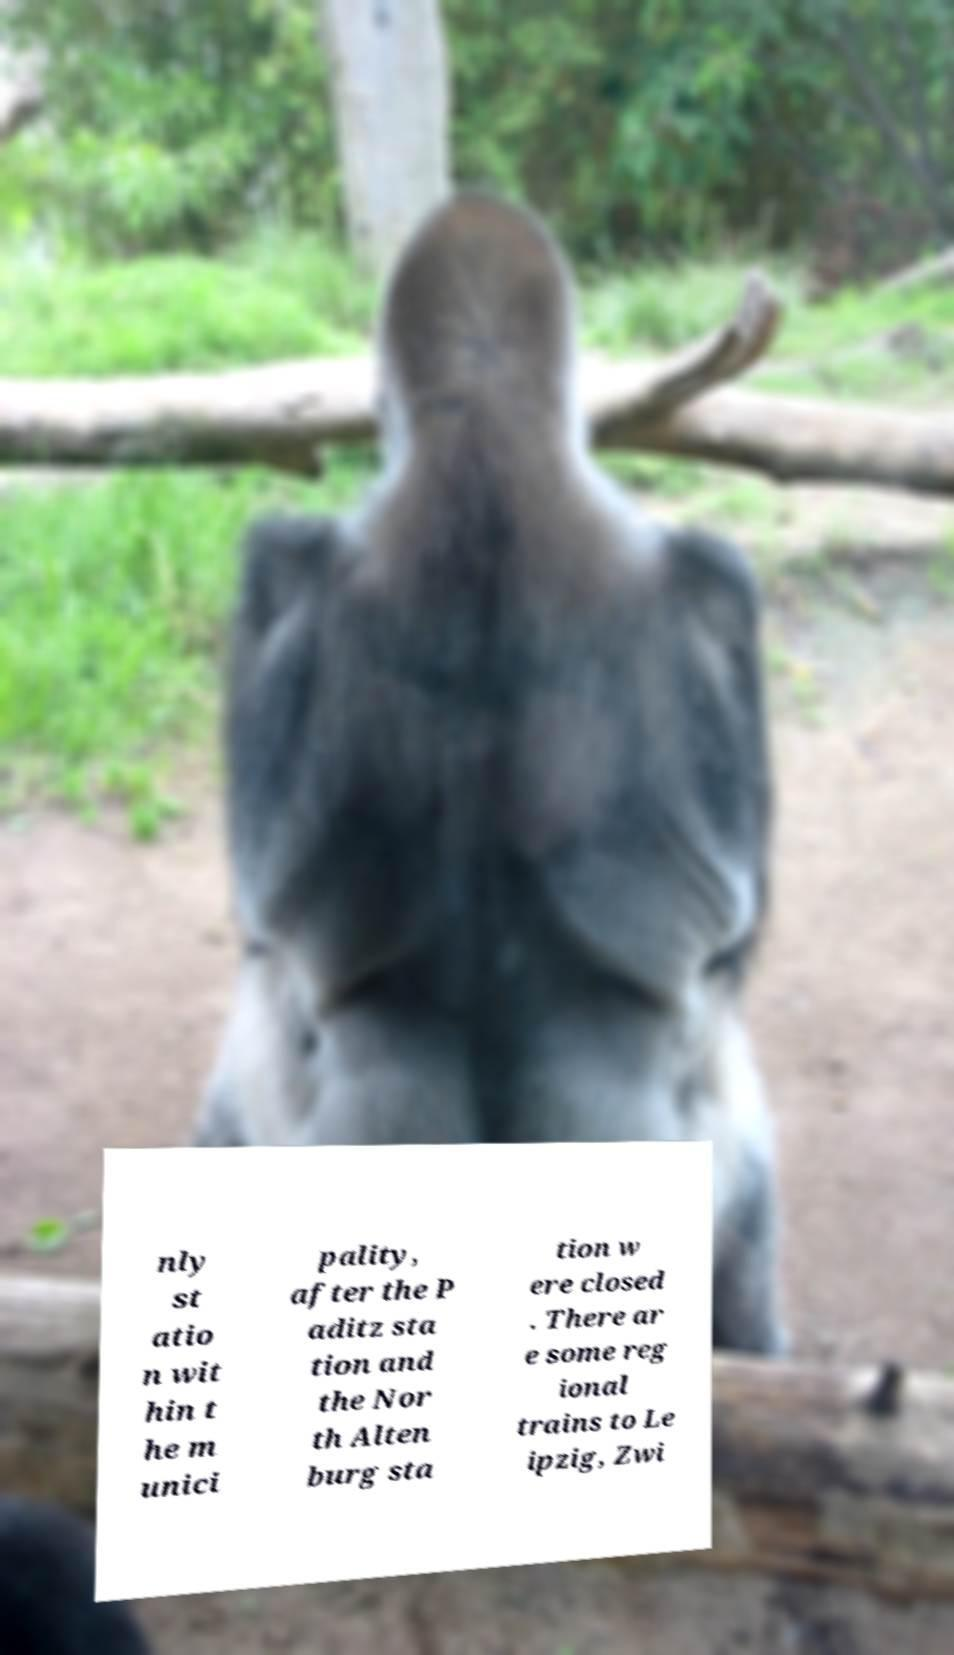Please read and relay the text visible in this image. What does it say? nly st atio n wit hin t he m unici pality, after the P aditz sta tion and the Nor th Alten burg sta tion w ere closed . There ar e some reg ional trains to Le ipzig, Zwi 